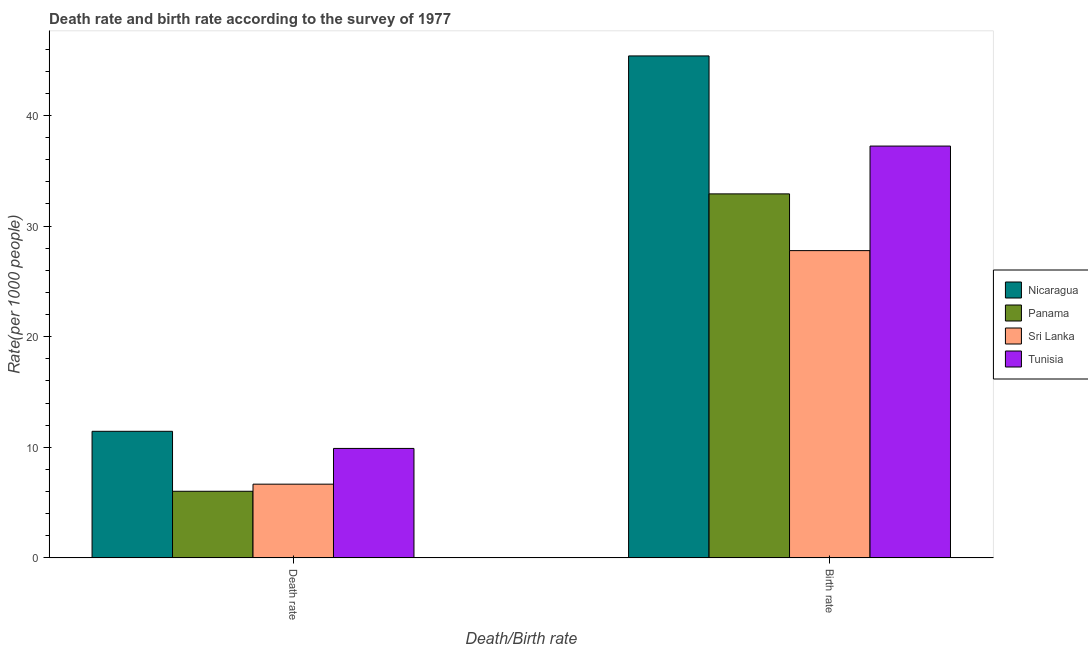How many different coloured bars are there?
Give a very brief answer. 4. Are the number of bars on each tick of the X-axis equal?
Give a very brief answer. Yes. How many bars are there on the 1st tick from the left?
Offer a terse response. 4. What is the label of the 1st group of bars from the left?
Your response must be concise. Death rate. What is the birth rate in Sri Lanka?
Your response must be concise. 27.78. Across all countries, what is the maximum death rate?
Give a very brief answer. 11.44. Across all countries, what is the minimum death rate?
Give a very brief answer. 6.02. In which country was the birth rate maximum?
Ensure brevity in your answer.  Nicaragua. In which country was the birth rate minimum?
Your answer should be compact. Sri Lanka. What is the total birth rate in the graph?
Keep it short and to the point. 143.29. What is the difference between the death rate in Sri Lanka and that in Tunisia?
Provide a short and direct response. -3.23. What is the difference between the birth rate in Nicaragua and the death rate in Panama?
Keep it short and to the point. 39.35. What is the average birth rate per country?
Keep it short and to the point. 35.82. What is the difference between the birth rate and death rate in Tunisia?
Provide a succinct answer. 27.33. What is the ratio of the death rate in Nicaragua to that in Tunisia?
Keep it short and to the point. 1.16. What does the 3rd bar from the left in Death rate represents?
Ensure brevity in your answer.  Sri Lanka. What does the 3rd bar from the right in Birth rate represents?
Your answer should be very brief. Panama. Are the values on the major ticks of Y-axis written in scientific E-notation?
Keep it short and to the point. No. How many legend labels are there?
Provide a succinct answer. 4. How are the legend labels stacked?
Keep it short and to the point. Vertical. What is the title of the graph?
Your answer should be very brief. Death rate and birth rate according to the survey of 1977. What is the label or title of the X-axis?
Make the answer very short. Death/Birth rate. What is the label or title of the Y-axis?
Offer a very short reply. Rate(per 1000 people). What is the Rate(per 1000 people) in Nicaragua in Death rate?
Your answer should be compact. 11.44. What is the Rate(per 1000 people) of Panama in Death rate?
Keep it short and to the point. 6.02. What is the Rate(per 1000 people) in Sri Lanka in Death rate?
Provide a succinct answer. 6.67. What is the Rate(per 1000 people) in Tunisia in Death rate?
Offer a terse response. 9.9. What is the Rate(per 1000 people) of Nicaragua in Birth rate?
Ensure brevity in your answer.  45.38. What is the Rate(per 1000 people) of Panama in Birth rate?
Make the answer very short. 32.91. What is the Rate(per 1000 people) in Sri Lanka in Birth rate?
Offer a terse response. 27.78. What is the Rate(per 1000 people) in Tunisia in Birth rate?
Make the answer very short. 37.23. Across all Death/Birth rate, what is the maximum Rate(per 1000 people) of Nicaragua?
Your answer should be very brief. 45.38. Across all Death/Birth rate, what is the maximum Rate(per 1000 people) in Panama?
Make the answer very short. 32.91. Across all Death/Birth rate, what is the maximum Rate(per 1000 people) of Sri Lanka?
Your answer should be very brief. 27.78. Across all Death/Birth rate, what is the maximum Rate(per 1000 people) in Tunisia?
Provide a short and direct response. 37.23. Across all Death/Birth rate, what is the minimum Rate(per 1000 people) in Nicaragua?
Provide a short and direct response. 11.44. Across all Death/Birth rate, what is the minimum Rate(per 1000 people) of Panama?
Your answer should be very brief. 6.02. Across all Death/Birth rate, what is the minimum Rate(per 1000 people) of Sri Lanka?
Keep it short and to the point. 6.67. Across all Death/Birth rate, what is the minimum Rate(per 1000 people) in Tunisia?
Make the answer very short. 9.9. What is the total Rate(per 1000 people) in Nicaragua in the graph?
Provide a short and direct response. 56.82. What is the total Rate(per 1000 people) of Panama in the graph?
Keep it short and to the point. 38.93. What is the total Rate(per 1000 people) of Sri Lanka in the graph?
Provide a succinct answer. 34.44. What is the total Rate(per 1000 people) in Tunisia in the graph?
Make the answer very short. 47.12. What is the difference between the Rate(per 1000 people) of Nicaragua in Death rate and that in Birth rate?
Your response must be concise. -33.93. What is the difference between the Rate(per 1000 people) in Panama in Death rate and that in Birth rate?
Provide a succinct answer. -26.88. What is the difference between the Rate(per 1000 people) of Sri Lanka in Death rate and that in Birth rate?
Give a very brief answer. -21.11. What is the difference between the Rate(per 1000 people) in Tunisia in Death rate and that in Birth rate?
Your answer should be very brief. -27.33. What is the difference between the Rate(per 1000 people) in Nicaragua in Death rate and the Rate(per 1000 people) in Panama in Birth rate?
Your answer should be compact. -21.46. What is the difference between the Rate(per 1000 people) of Nicaragua in Death rate and the Rate(per 1000 people) of Sri Lanka in Birth rate?
Your answer should be compact. -16.33. What is the difference between the Rate(per 1000 people) of Nicaragua in Death rate and the Rate(per 1000 people) of Tunisia in Birth rate?
Ensure brevity in your answer.  -25.79. What is the difference between the Rate(per 1000 people) of Panama in Death rate and the Rate(per 1000 people) of Sri Lanka in Birth rate?
Keep it short and to the point. -21.75. What is the difference between the Rate(per 1000 people) of Panama in Death rate and the Rate(per 1000 people) of Tunisia in Birth rate?
Provide a succinct answer. -31.2. What is the difference between the Rate(per 1000 people) in Sri Lanka in Death rate and the Rate(per 1000 people) in Tunisia in Birth rate?
Give a very brief answer. -30.56. What is the average Rate(per 1000 people) of Nicaragua per Death/Birth rate?
Provide a succinct answer. 28.41. What is the average Rate(per 1000 people) in Panama per Death/Birth rate?
Your response must be concise. 19.46. What is the average Rate(per 1000 people) in Sri Lanka per Death/Birth rate?
Give a very brief answer. 17.22. What is the average Rate(per 1000 people) of Tunisia per Death/Birth rate?
Offer a terse response. 23.56. What is the difference between the Rate(per 1000 people) in Nicaragua and Rate(per 1000 people) in Panama in Death rate?
Keep it short and to the point. 5.42. What is the difference between the Rate(per 1000 people) of Nicaragua and Rate(per 1000 people) of Sri Lanka in Death rate?
Offer a terse response. 4.78. What is the difference between the Rate(per 1000 people) of Nicaragua and Rate(per 1000 people) of Tunisia in Death rate?
Your answer should be very brief. 1.55. What is the difference between the Rate(per 1000 people) in Panama and Rate(per 1000 people) in Sri Lanka in Death rate?
Your answer should be very brief. -0.64. What is the difference between the Rate(per 1000 people) of Panama and Rate(per 1000 people) of Tunisia in Death rate?
Provide a succinct answer. -3.87. What is the difference between the Rate(per 1000 people) of Sri Lanka and Rate(per 1000 people) of Tunisia in Death rate?
Provide a succinct answer. -3.23. What is the difference between the Rate(per 1000 people) in Nicaragua and Rate(per 1000 people) in Panama in Birth rate?
Provide a succinct answer. 12.47. What is the difference between the Rate(per 1000 people) in Nicaragua and Rate(per 1000 people) in Tunisia in Birth rate?
Provide a short and direct response. 8.15. What is the difference between the Rate(per 1000 people) of Panama and Rate(per 1000 people) of Sri Lanka in Birth rate?
Provide a short and direct response. 5.13. What is the difference between the Rate(per 1000 people) of Panama and Rate(per 1000 people) of Tunisia in Birth rate?
Your response must be concise. -4.32. What is the difference between the Rate(per 1000 people) of Sri Lanka and Rate(per 1000 people) of Tunisia in Birth rate?
Your answer should be very brief. -9.45. What is the ratio of the Rate(per 1000 people) in Nicaragua in Death rate to that in Birth rate?
Your response must be concise. 0.25. What is the ratio of the Rate(per 1000 people) in Panama in Death rate to that in Birth rate?
Make the answer very short. 0.18. What is the ratio of the Rate(per 1000 people) in Sri Lanka in Death rate to that in Birth rate?
Your answer should be compact. 0.24. What is the ratio of the Rate(per 1000 people) of Tunisia in Death rate to that in Birth rate?
Provide a short and direct response. 0.27. What is the difference between the highest and the second highest Rate(per 1000 people) of Nicaragua?
Make the answer very short. 33.93. What is the difference between the highest and the second highest Rate(per 1000 people) of Panama?
Keep it short and to the point. 26.88. What is the difference between the highest and the second highest Rate(per 1000 people) in Sri Lanka?
Ensure brevity in your answer.  21.11. What is the difference between the highest and the second highest Rate(per 1000 people) in Tunisia?
Provide a short and direct response. 27.33. What is the difference between the highest and the lowest Rate(per 1000 people) of Nicaragua?
Offer a very short reply. 33.93. What is the difference between the highest and the lowest Rate(per 1000 people) in Panama?
Give a very brief answer. 26.88. What is the difference between the highest and the lowest Rate(per 1000 people) of Sri Lanka?
Provide a short and direct response. 21.11. What is the difference between the highest and the lowest Rate(per 1000 people) in Tunisia?
Your response must be concise. 27.33. 